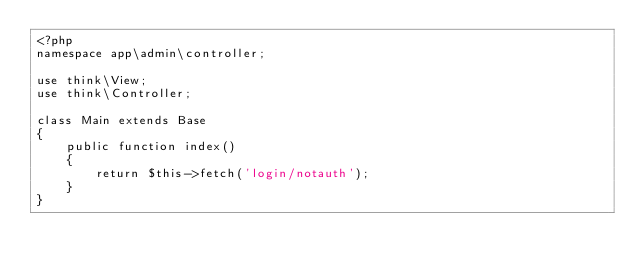Convert code to text. <code><loc_0><loc_0><loc_500><loc_500><_PHP_><?php
namespace app\admin\controller;

use think\View;
use think\Controller;

class Main extends Base
{
    public function index()
    {            	
        return $this->fetch('login/notauth');
    }
}</code> 